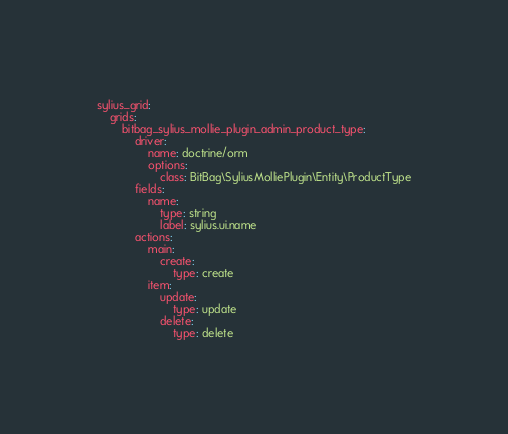Convert code to text. <code><loc_0><loc_0><loc_500><loc_500><_YAML_>sylius_grid:
    grids:
        bitbag_sylius_mollie_plugin_admin_product_type:
            driver:
                name: doctrine/orm
                options:
                    class: BitBag\SyliusMolliePlugin\Entity\ProductType
            fields:
                name:
                    type: string
                    label: sylius.ui.name
            actions:
                main:
                    create:
                        type: create
                item:
                    update:
                        type: update
                    delete:
                        type: delete
</code> 